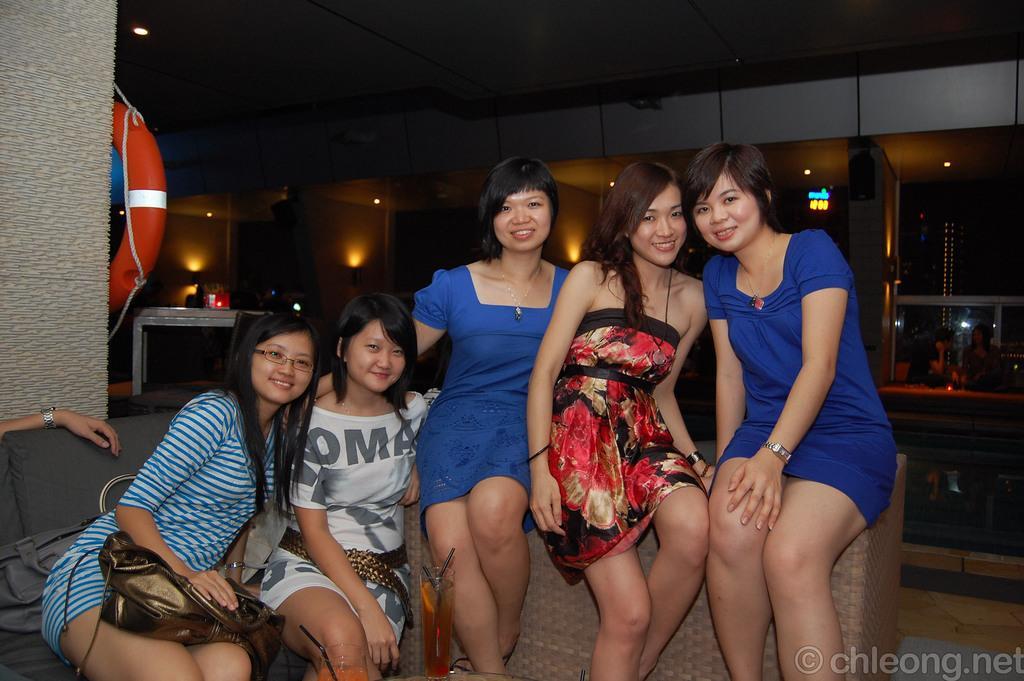Can you describe this image briefly? In this picture we can see few women sitting on a sofa. There is a woman on left side kept a bag on her lap. There are some lights and few people are visible in the background. A red object is visible on left side. 